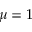<formula> <loc_0><loc_0><loc_500><loc_500>\mu = 1</formula> 